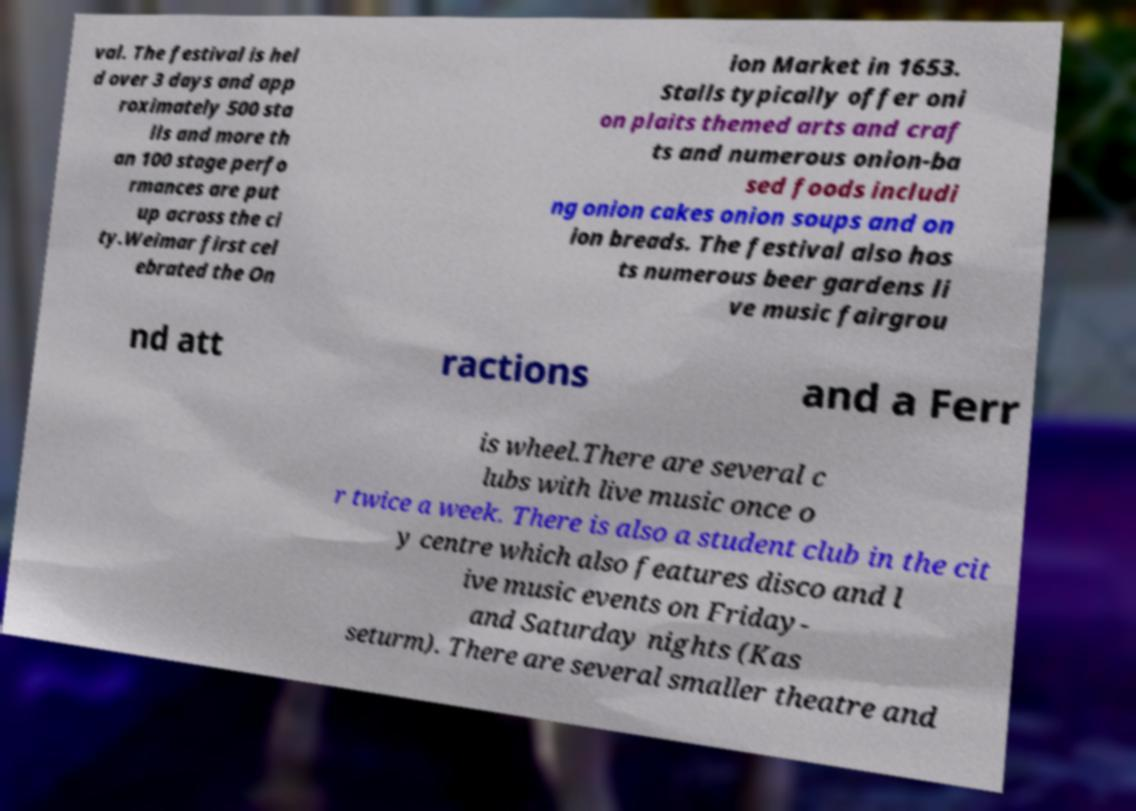I need the written content from this picture converted into text. Can you do that? val. The festival is hel d over 3 days and app roximately 500 sta lls and more th an 100 stage perfo rmances are put up across the ci ty.Weimar first cel ebrated the On ion Market in 1653. Stalls typically offer oni on plaits themed arts and craf ts and numerous onion-ba sed foods includi ng onion cakes onion soups and on ion breads. The festival also hos ts numerous beer gardens li ve music fairgrou nd att ractions and a Ferr is wheel.There are several c lubs with live music once o r twice a week. There is also a student club in the cit y centre which also features disco and l ive music events on Friday- and Saturday nights (Kas seturm). There are several smaller theatre and 